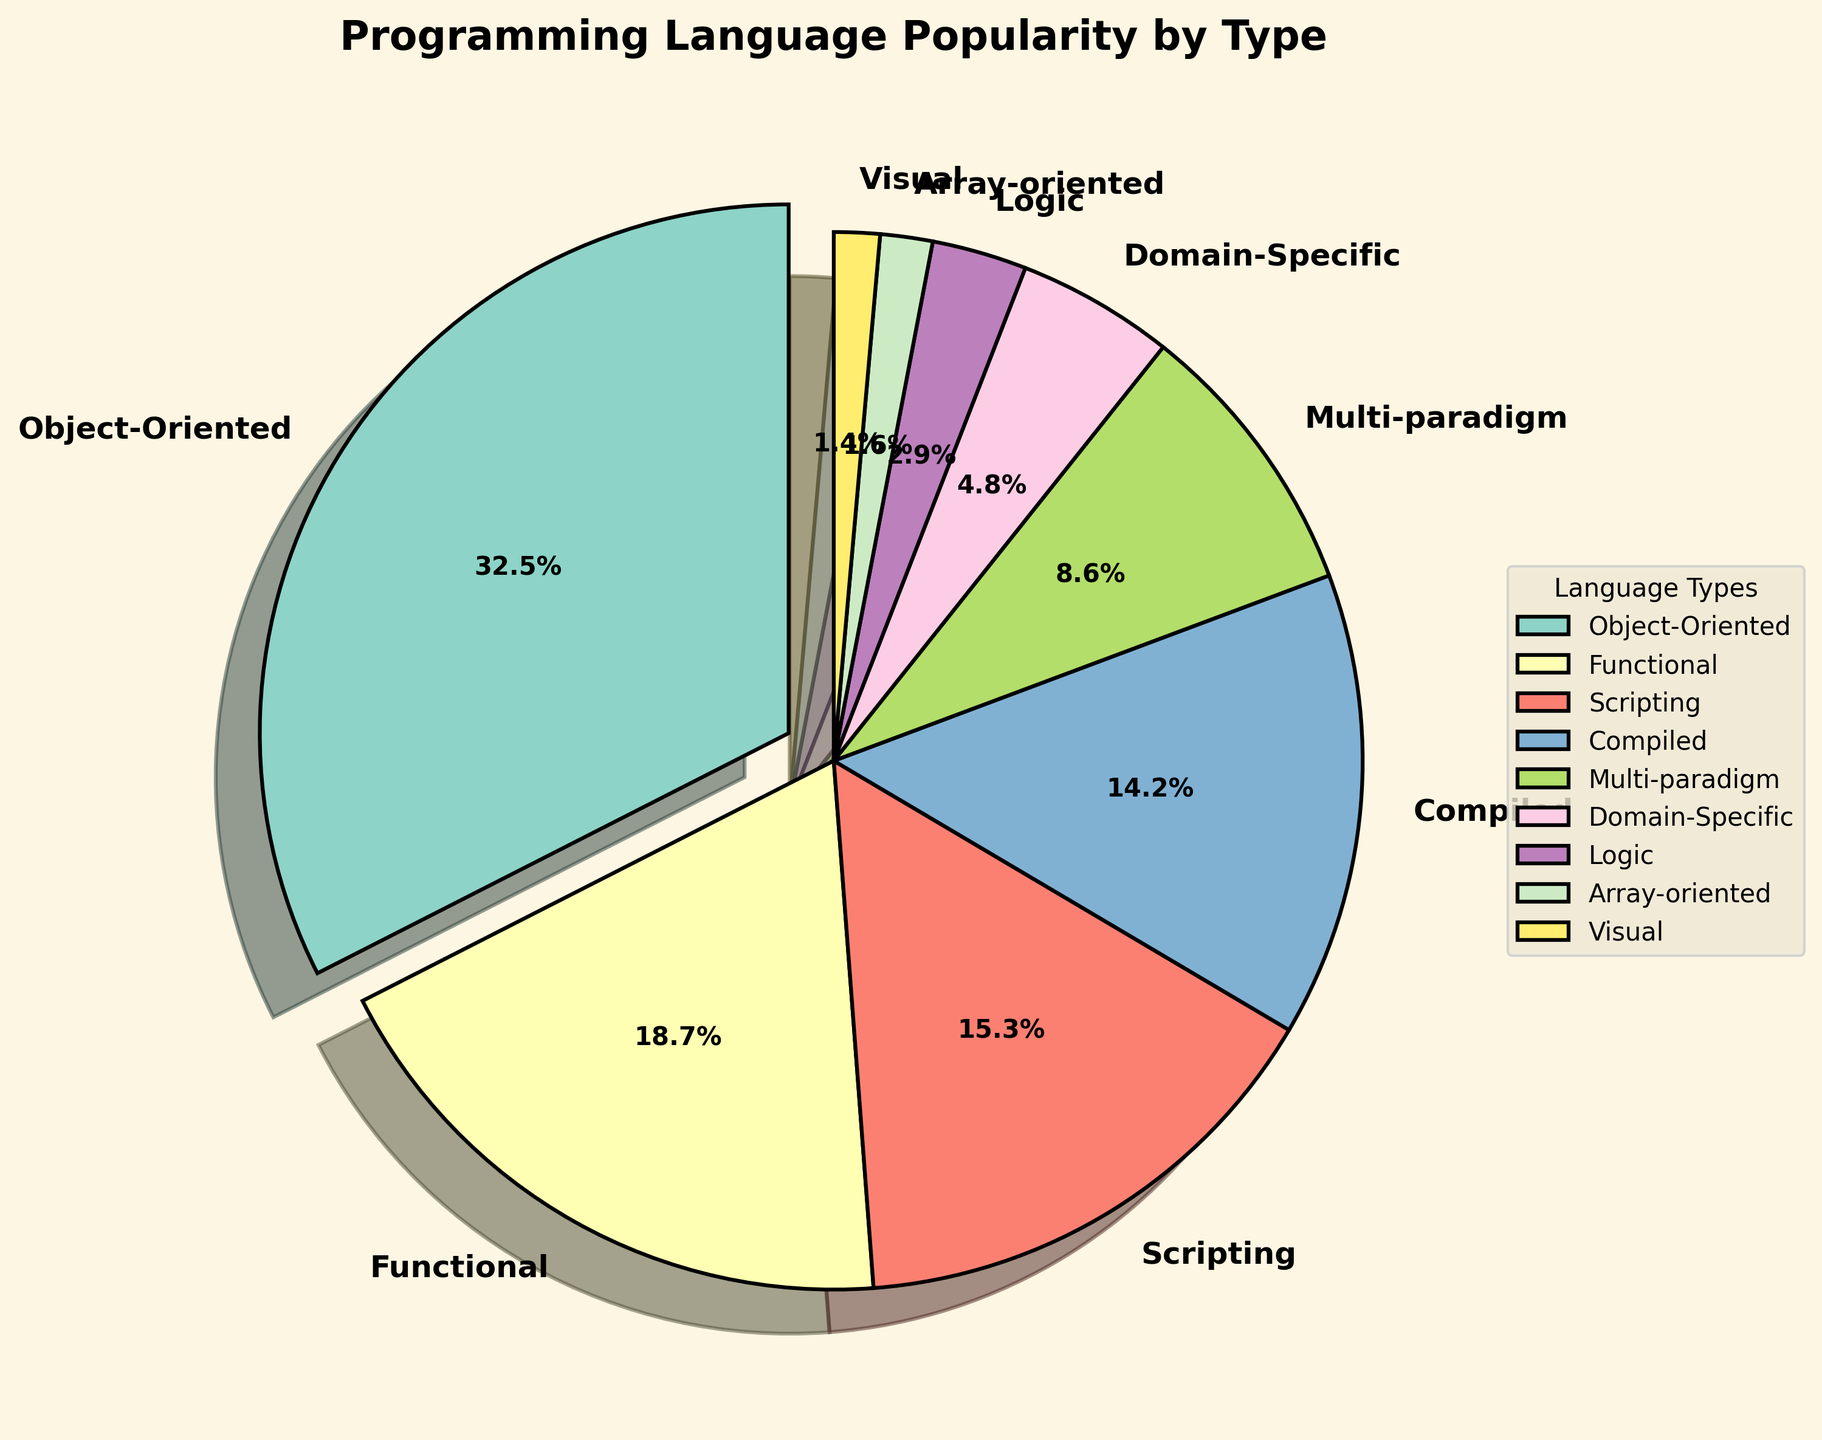what is the most popular language type among developers? To determine the most popular language type, we need to find the segment with the highest percentage. By looking at the figure, we see that "Object-Oriented" has the largest slice.
Answer: Object-Oriented which is more popular, scripting languages or compiled languages? To determine which language type is more popular, compare the percentages of "Scripting" and "Compiled" languages in the figure. "Scripting" languages have a 15.3% share, while "Compiled" languages have a 14.2% share.
Answer: Scripting what is the combined percentage of functional and multi-paradigm languages? To find the combined percentage, add the values of "Functional" (18.7%) and "Multi-paradigm" (8.6%). The calculation is 18.7 + 8.6.
Answer: 27.3% how much more popular are object-oriented languages than logic languages? Subtract the percentage of "Logic" languages (2.9%) from "Object-Oriented" languages (32.5%). The calculation is 32.5 - 2.9.
Answer: 29.6% which language type has the smallest representation, and what is its percentage? To find the least represented language type, locate the smallest segment in the pie chart, which is "Visual" languages, with a percentage of 1.4%.
Answer: Visual, 1.4% how many different language types have a representation of less than 10%? Count the segments in the pie chart that have percentages less than 10%. These are "Multi-paradigm," "Domain-Specific," "Logic," "Array-oriented," and "Visual," summing up to 5 types.
Answer: 5 which language type has a slice shown at an angle due to a distinct separation? To identify this, observe the "explode" parameter in the figure. The "Object-Oriented" language type, with the highest percentage (32.5%), has an emphasized slice.
Answer: Object-Oriented how does the popularity of compiled languages compare to domain-specific languages? Compare the percentages of "Compiled" (14.2%) and "Domain-Specific" (4.8%) languages. "Compiled" languages are more popular.
Answer: Compiled what is the average percentage representation of scripting, compiled, and domain-specific languages? To find the average, add the percentages of "Scripting" (15.3%), "Compiled" (14.2%), and "Domain-Specific" (4.8%), then divide by 3. The calculation is (15.3 + 14.2 + 4.8) / 3.
Answer: 11.43% how does the percentage of functional languages compare to the sum of logic and array-oriented languages? First, sum the percentages of "Logic" (2.9%) and "Array-oriented" (1.6%), which is 4.5%. Then compare it to the "Functional" languages percentage (18.7%). "Functional" is higher.
Answer: Functional 